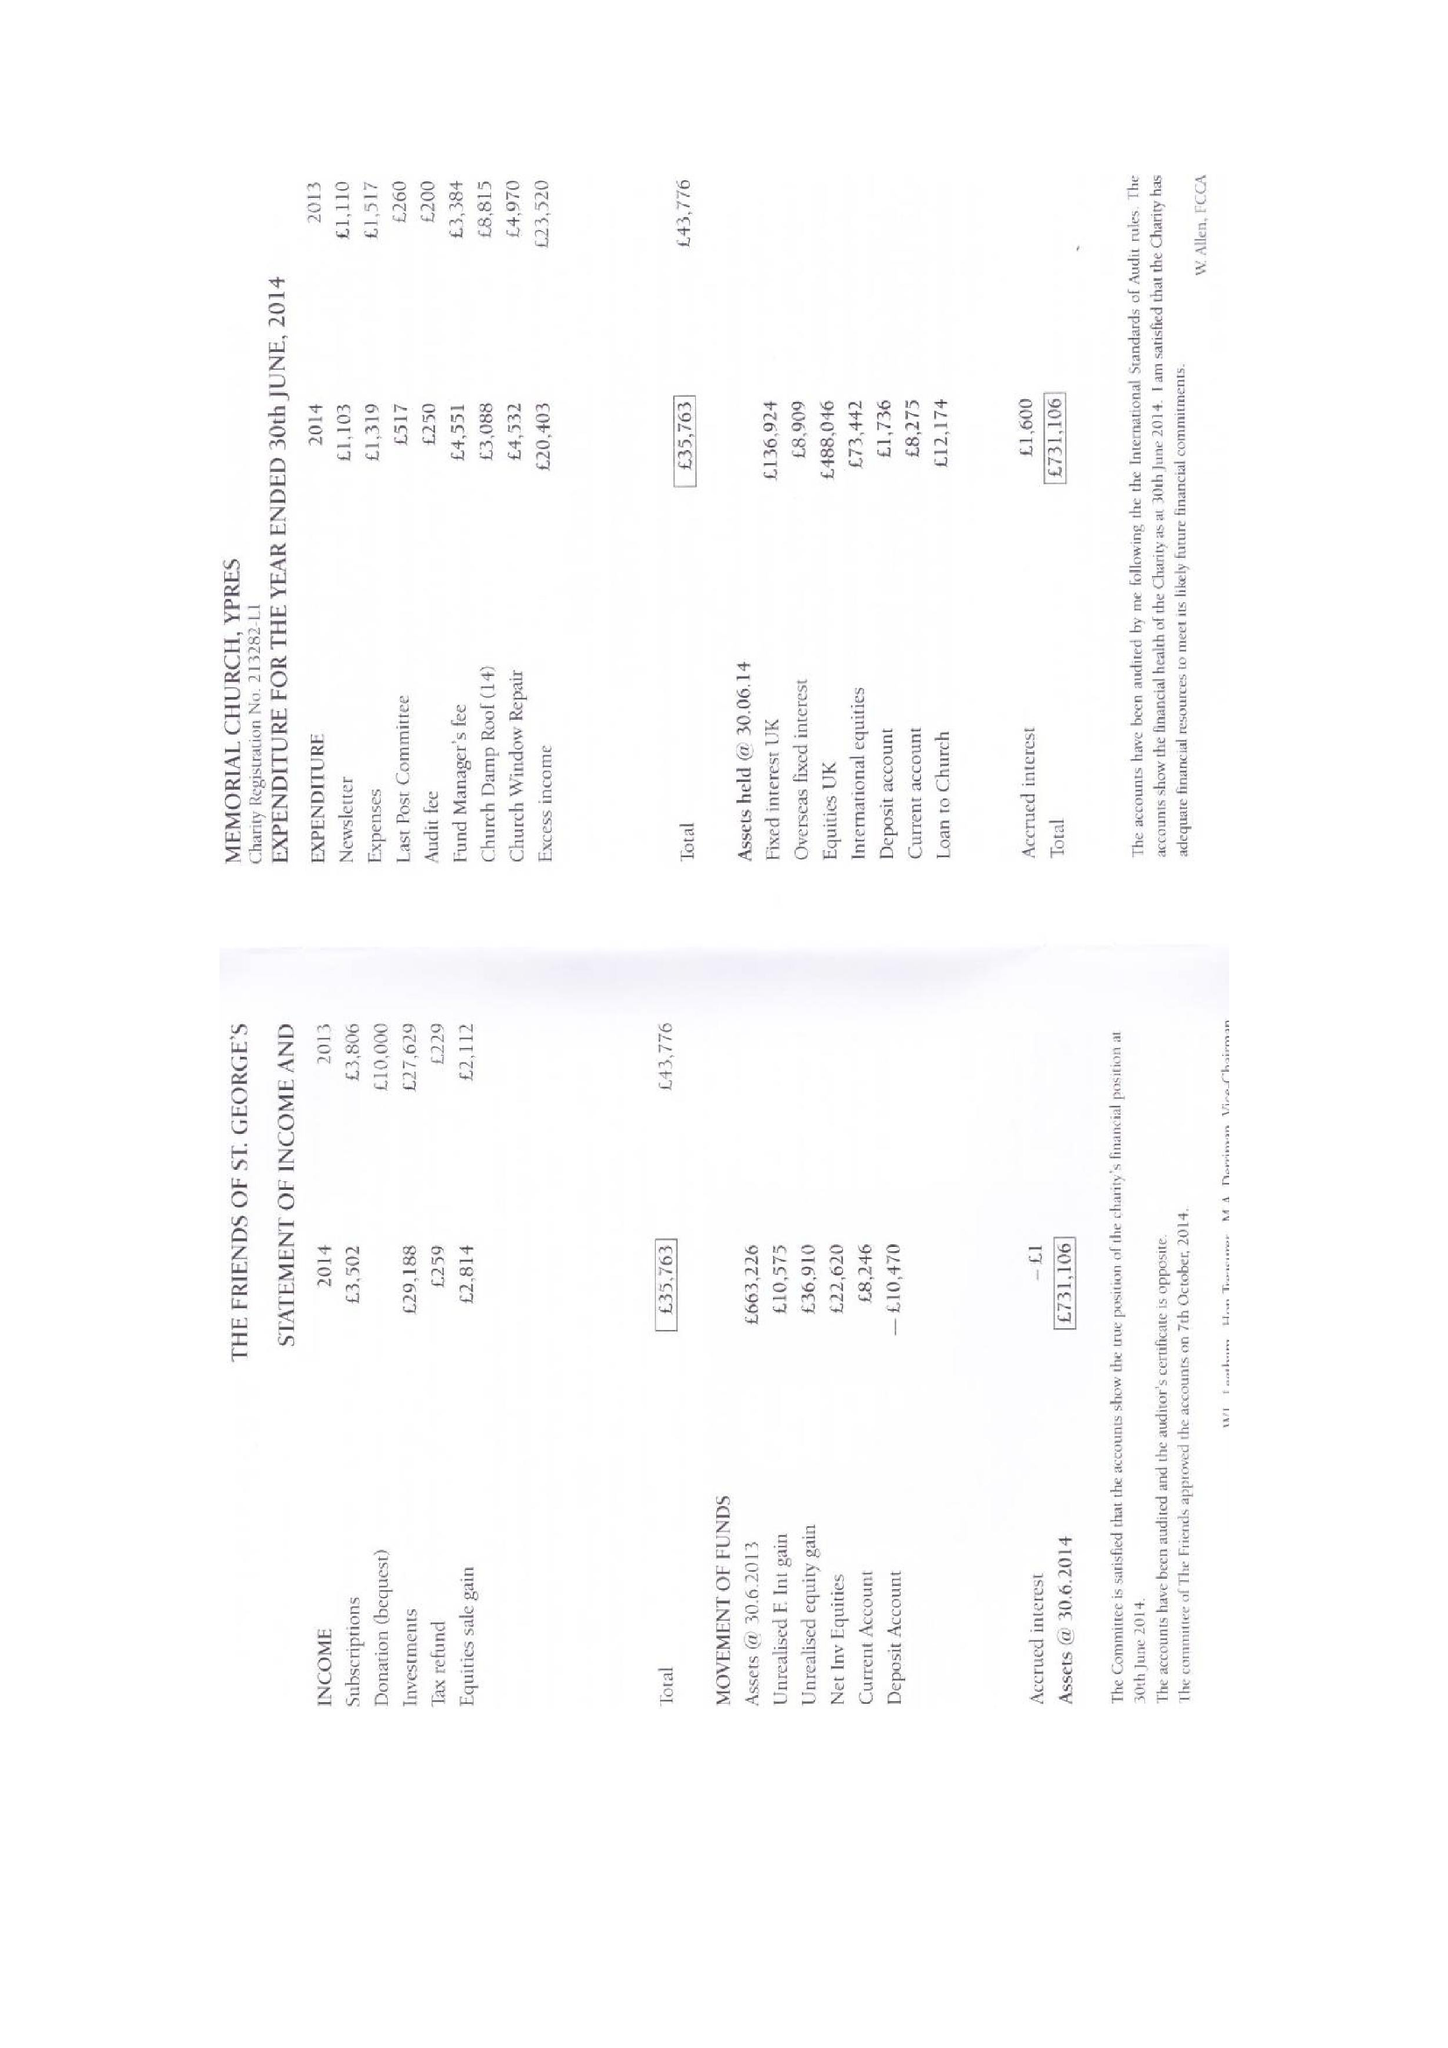What is the value for the charity_name?
Answer the question using a single word or phrase. The Friends Of St George's Memorial Church Ypres 